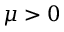<formula> <loc_0><loc_0><loc_500><loc_500>\mu > 0</formula> 